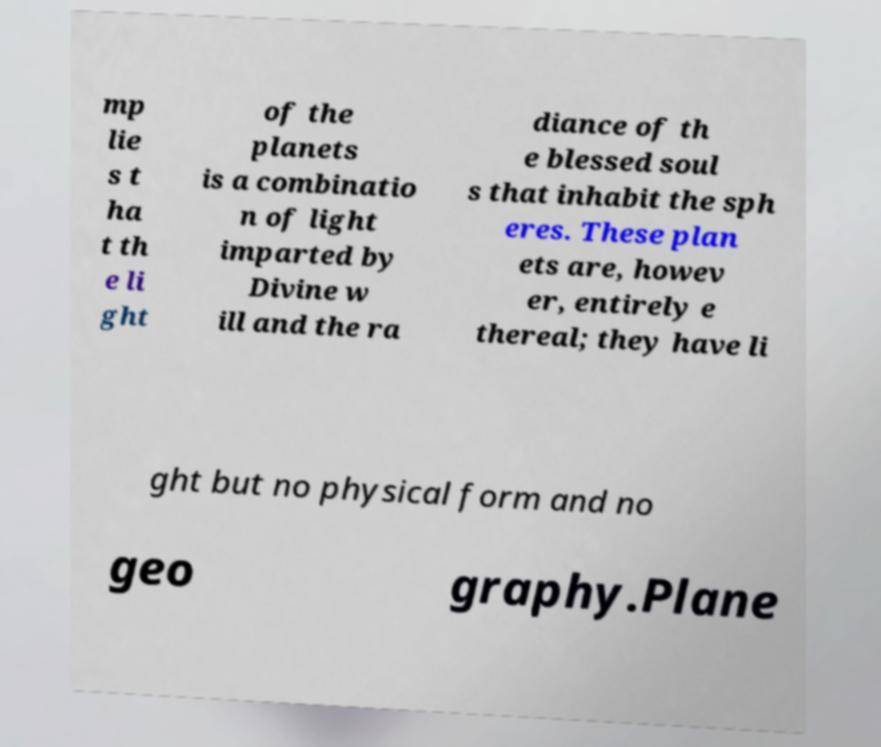What messages or text are displayed in this image? I need them in a readable, typed format. mp lie s t ha t th e li ght of the planets is a combinatio n of light imparted by Divine w ill and the ra diance of th e blessed soul s that inhabit the sph eres. These plan ets are, howev er, entirely e thereal; they have li ght but no physical form and no geo graphy.Plane 